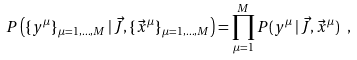Convert formula to latex. <formula><loc_0><loc_0><loc_500><loc_500>P \left ( \{ y ^ { \mu } \} _ { \mu = 1 , \dots , M } \, | \, \vec { J } , \{ \vec { x } ^ { \mu } \} _ { \mu = 1 , \dots , M } \right ) = \prod _ { \mu = 1 } ^ { M } P ( y ^ { \mu } \, | \, \vec { J } , \vec { x } ^ { \mu } ) \ ,</formula> 